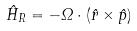Convert formula to latex. <formula><loc_0><loc_0><loc_500><loc_500>\hat { H } _ { R } = - \Omega \cdot ( \hat { r } \times \hat { p } )</formula> 